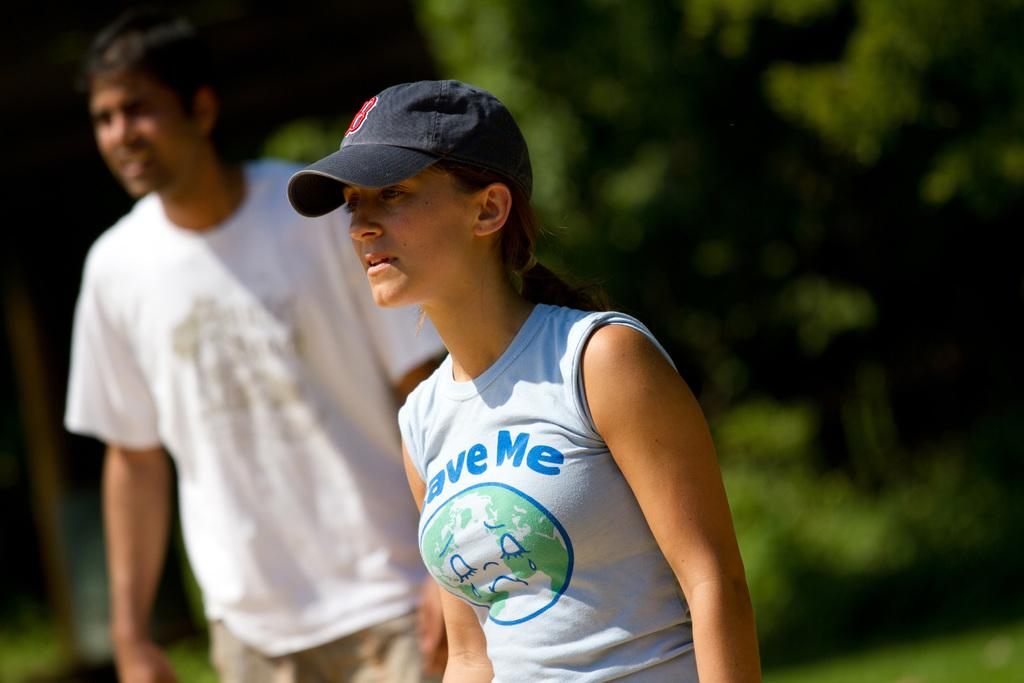<image>
Present a compact description of the photo's key features. A woman's shirt reads "save me," it is about the planet earth. 